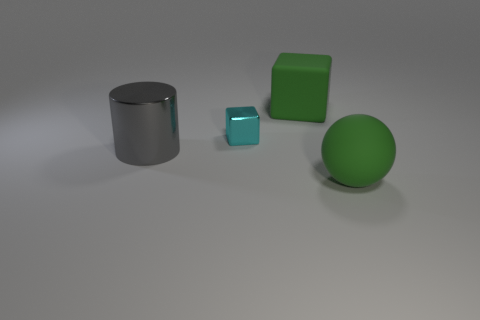What color is the block that is in front of the green cube?
Your answer should be compact. Cyan. There is a rubber cube that is the same size as the green ball; what color is it?
Offer a very short reply. Green. Is the gray metallic thing the same size as the cyan metal thing?
Provide a succinct answer. No. What number of large green balls are right of the big rubber ball?
Provide a succinct answer. 0. What number of objects are matte objects in front of the cyan shiny thing or blue matte cylinders?
Provide a succinct answer. 1. Is the number of cyan cubes behind the gray metallic thing greater than the number of small metal cubes that are to the right of the small cyan cube?
Offer a very short reply. Yes. Is the size of the rubber sphere the same as the green thing that is behind the cyan metal thing?
Your answer should be compact. Yes. How many cubes are green matte things or large purple shiny objects?
Provide a short and direct response. 1. What size is the thing that is the same material as the large green block?
Ensure brevity in your answer.  Large. Is the size of the green thing that is behind the cylinder the same as the metal object left of the small object?
Your answer should be compact. Yes. 